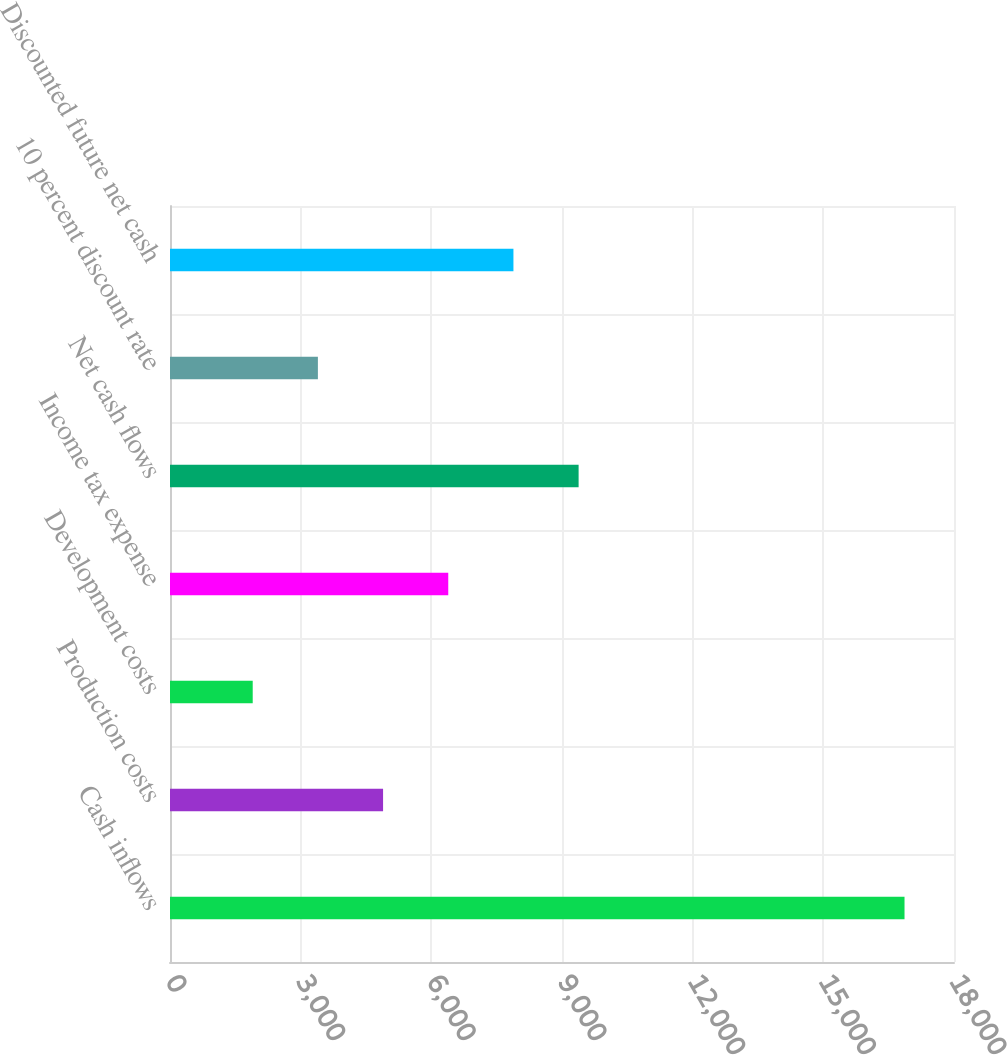<chart> <loc_0><loc_0><loc_500><loc_500><bar_chart><fcel>Cash inflows<fcel>Production costs<fcel>Development costs<fcel>Income tax expense<fcel>Net cash flows<fcel>10 percent discount rate<fcel>Discounted future net cash<nl><fcel>16864<fcel>4892<fcel>1899<fcel>6388.5<fcel>9381.5<fcel>3395.5<fcel>7885<nl></chart> 